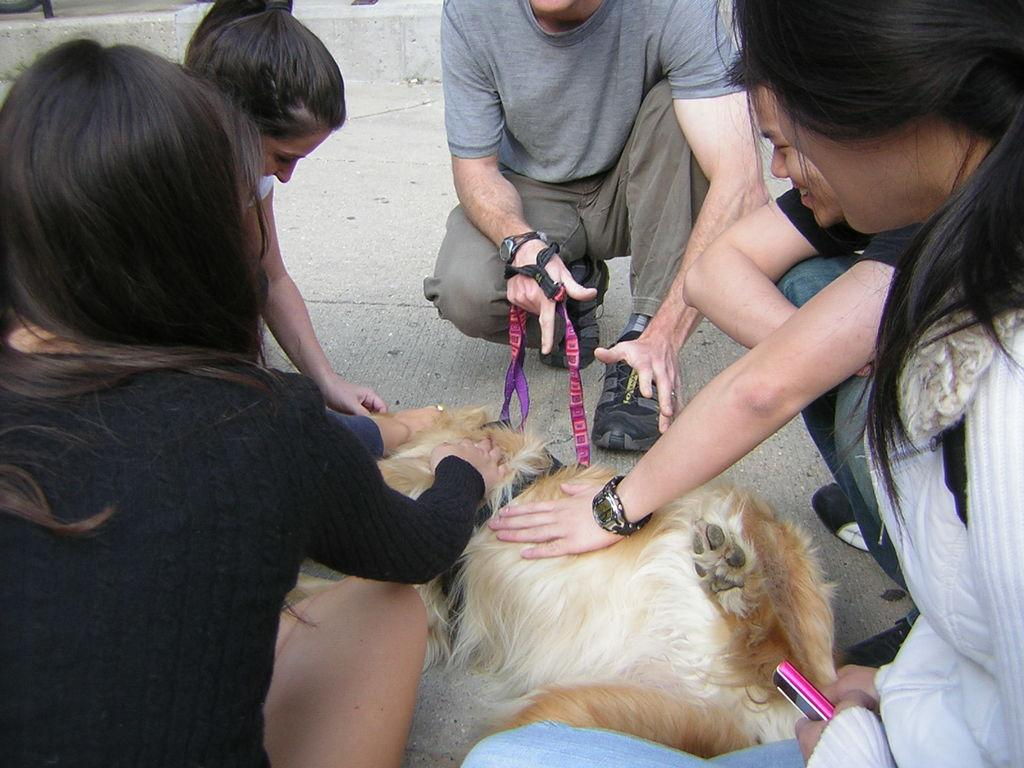What type of animal can be seen in the image? There is a dog in the image. What are the people in the image doing? The people in the image are sitting on the road. What type of hammer can be seen in the image? There is no hammer present in the image. What range can be seen in the image? There is no reference to a range in the image. 